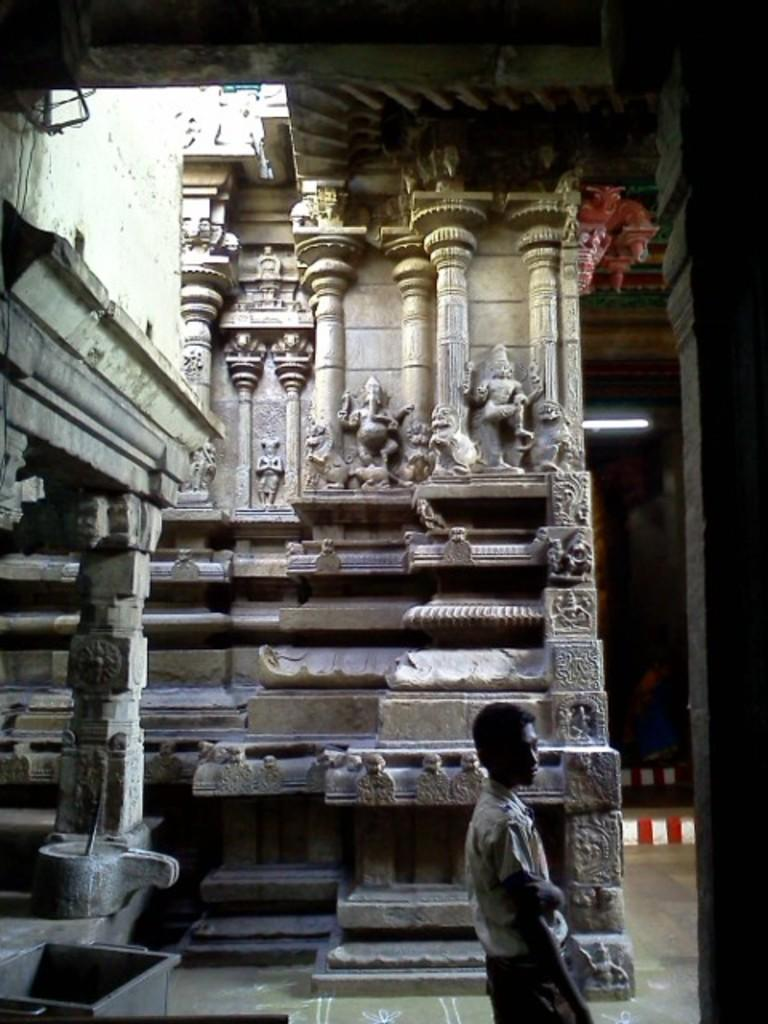What type of decorations can be seen on the pillars and walls in the image? There are stone carvings on the pillars and walls in the image. What kind of place does the image appear to depict? The setting appears to be a temple. Can you describe the person in the image? There is a man standing in the image. What object is located on the left side of the image? There is a metal box on the left side of the image. What is the man's opinion on the family in the image? There is no family present in the image, and the man's opinion cannot be determined from the image. 